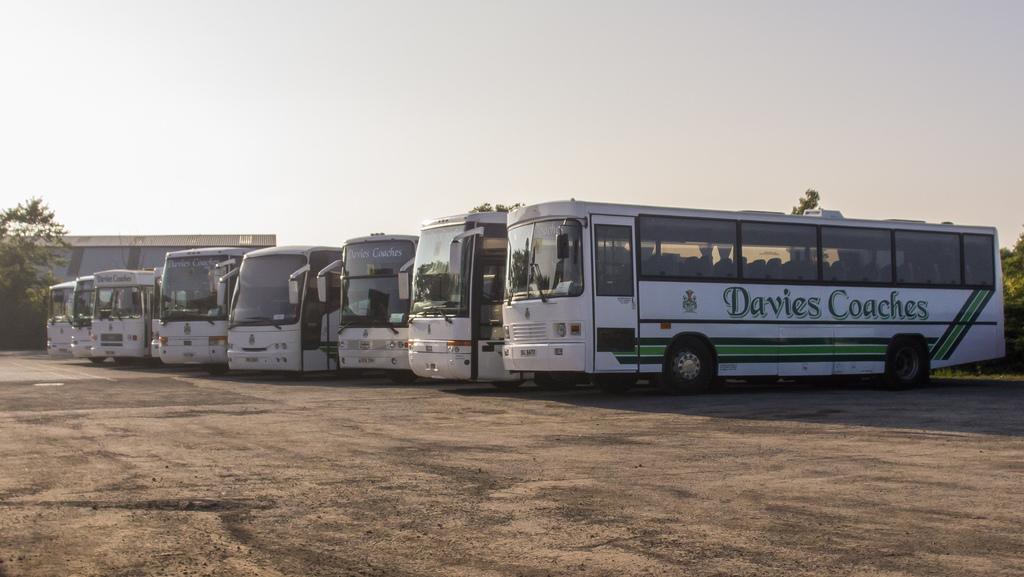What type of vehicles are parked in the image? There are buses parked on land in the image. What can be seen on the left side of the image? Trees are present on the left side of the image. What color is the sky in the image? The sky is blue in the image. What type of brass instrument is being played by the trees in the image? There is no brass instrument being played by the trees in the image, as trees are not capable of playing musical instruments. 